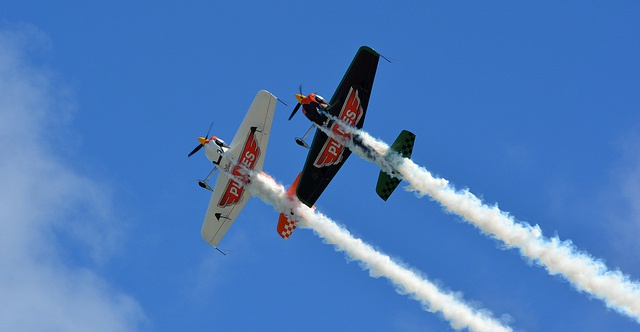Describe the objects in this image and their specific colors. I can see airplane in blue, black, gray, and maroon tones and airplane in blue and gray tones in this image. 